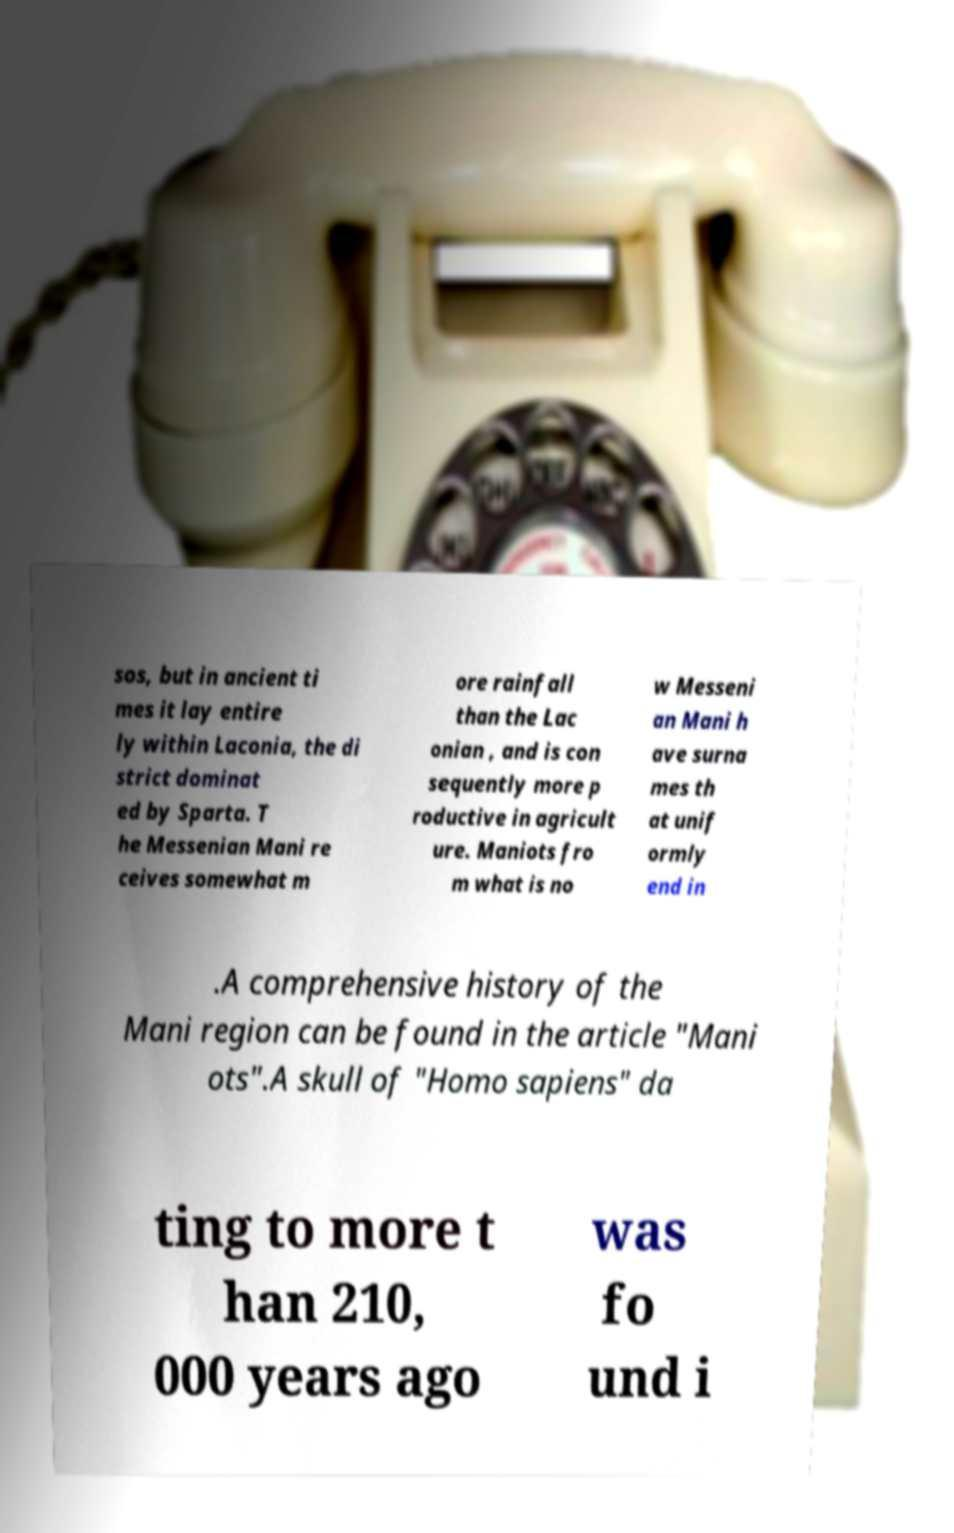For documentation purposes, I need the text within this image transcribed. Could you provide that? sos, but in ancient ti mes it lay entire ly within Laconia, the di strict dominat ed by Sparta. T he Messenian Mani re ceives somewhat m ore rainfall than the Lac onian , and is con sequently more p roductive in agricult ure. Maniots fro m what is no w Messeni an Mani h ave surna mes th at unif ormly end in .A comprehensive history of the Mani region can be found in the article "Mani ots".A skull of "Homo sapiens" da ting to more t han 210, 000 years ago was fo und i 